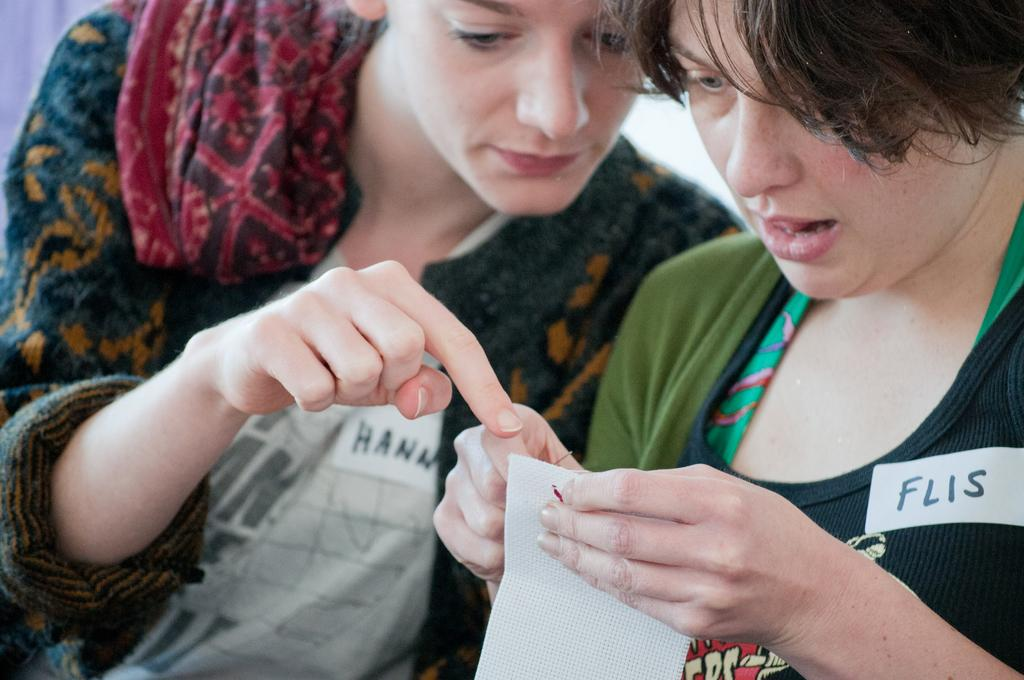How many people are in the image? There are two persons in the image. Can you describe the gender of one of the persons? One of the persons is a woman. Where is the woman located in the image? The woman is on the right side of the image. What is the woman holding in her hands? The woman is holding a paper and a needle. What type of desk can be seen in the image? There is no desk present in the image. How does the tramp contribute to the scene in the image? There is no tramp present in the image, so it cannot contribute to the scene. 